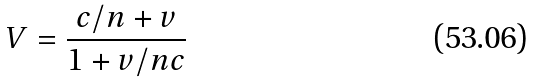Convert formula to latex. <formula><loc_0><loc_0><loc_500><loc_500>V = \frac { c / n + v } { 1 + v / n c }</formula> 